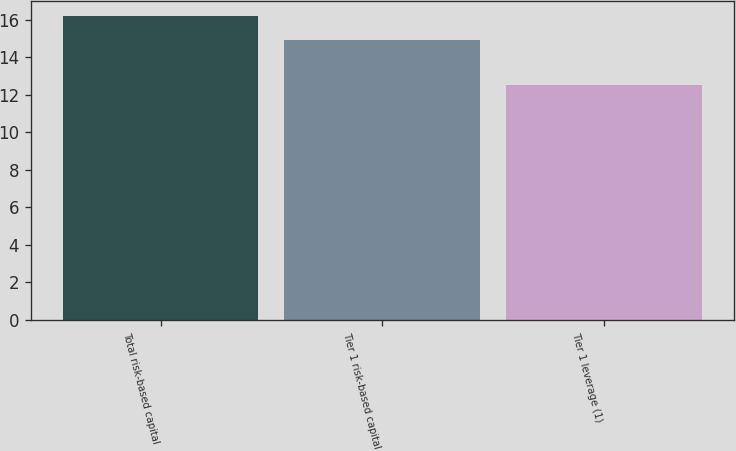Convert chart to OTSL. <chart><loc_0><loc_0><loc_500><loc_500><bar_chart><fcel>Total risk-based capital<fcel>Tier 1 risk-based capital<fcel>Tier 1 leverage (1)<nl><fcel>16.2<fcel>14.9<fcel>12.5<nl></chart> 